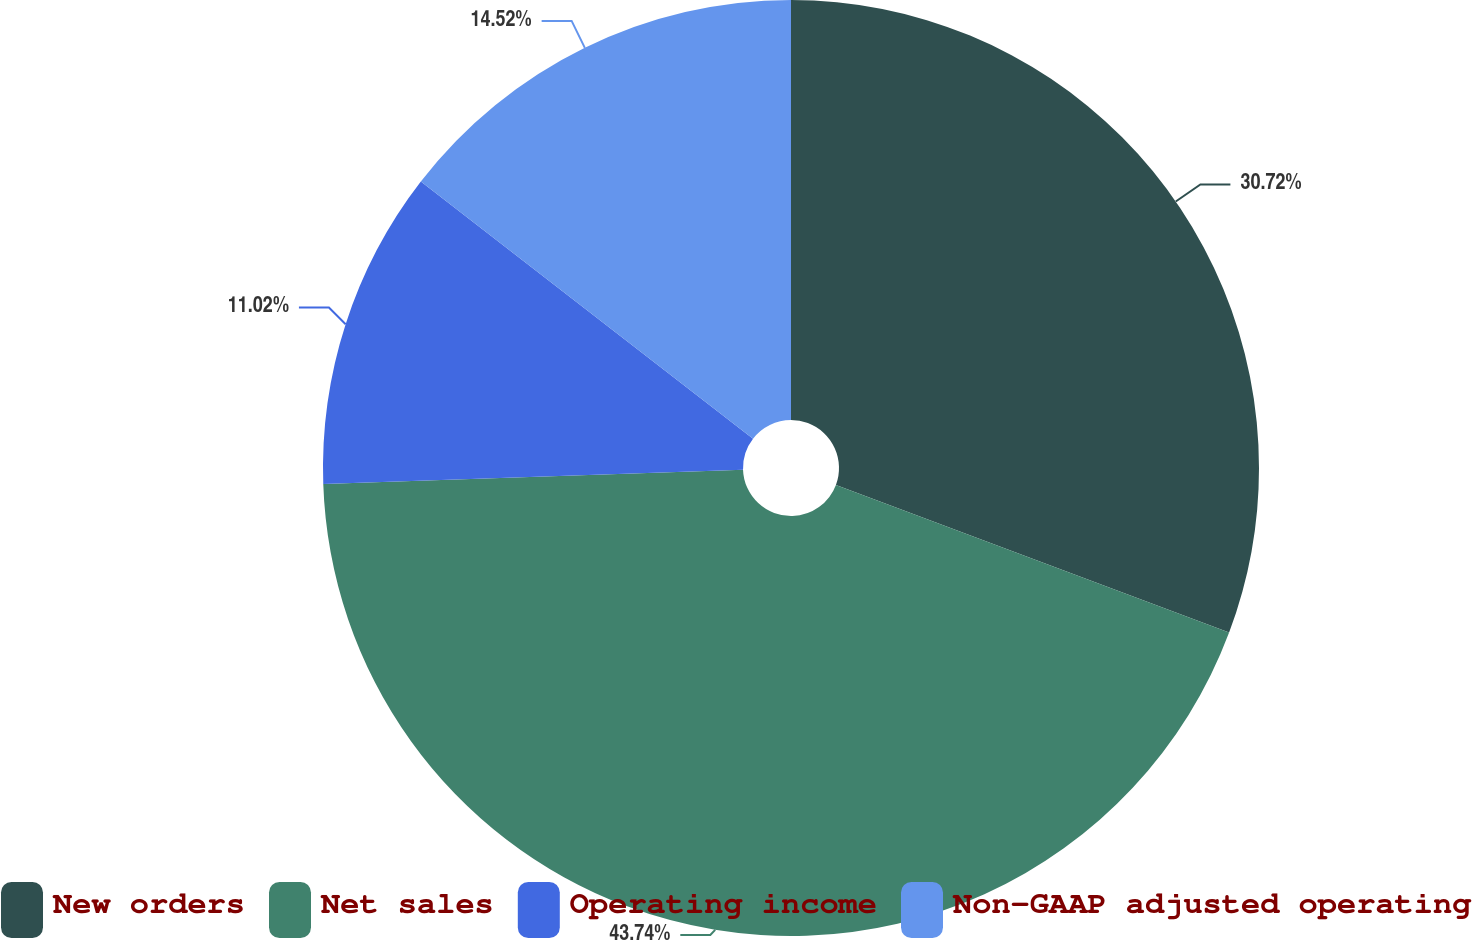Convert chart. <chart><loc_0><loc_0><loc_500><loc_500><pie_chart><fcel>New orders<fcel>Net sales<fcel>Operating income<fcel>Non-GAAP adjusted operating<nl><fcel>30.72%<fcel>43.74%<fcel>11.02%<fcel>14.52%<nl></chart> 